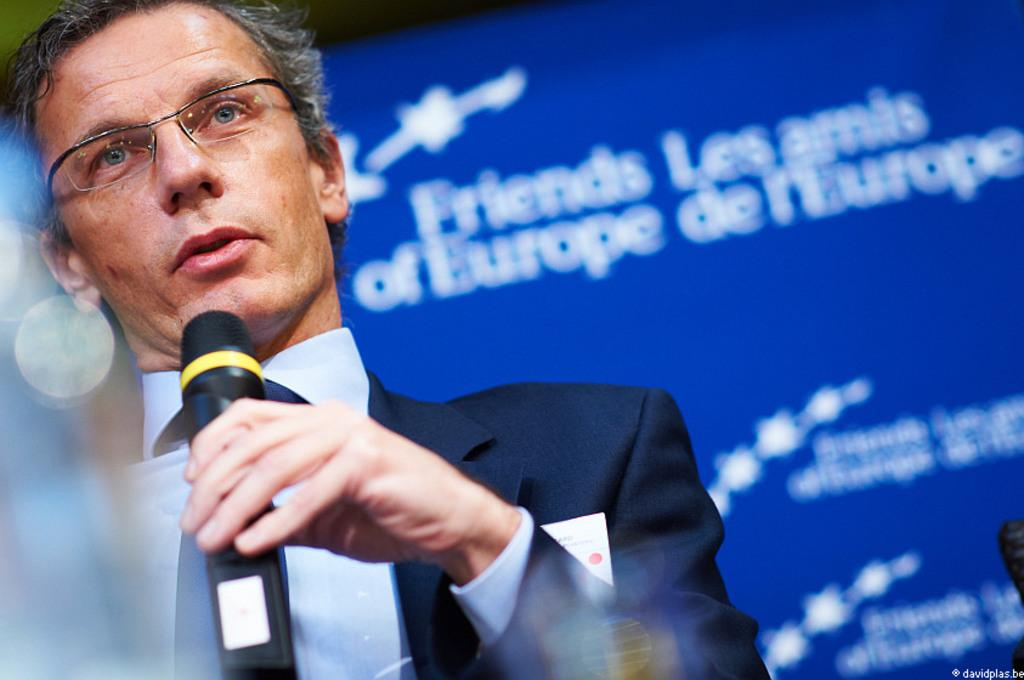Who is in the image? There is a man in the image. What is the man wearing? The man is wearing a black suit. What is the man doing in the image? The man is sitting and talking. What object is the man holding? The man is holding a microphone. What color is the banner in the background of the image? The banner in the background of the image is blue. What type of twist can be seen in the man's hair in the image? There is no twist visible in the man's hair in the image. Can you tell me how many uncles are present in the image? There is no uncle mentioned or depicted in the image. 